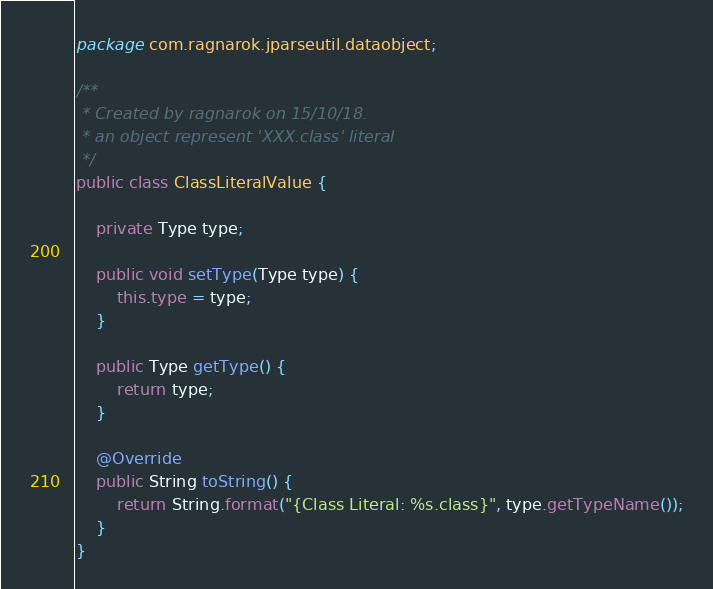<code> <loc_0><loc_0><loc_500><loc_500><_Java_>package com.ragnarok.jparseutil.dataobject;

/**
 * Created by ragnarok on 15/10/18.
 * an object represent 'XXX.class' literal
 */
public class ClassLiteralValue {
    
    private Type type;
    
    public void setType(Type type) {
        this.type = type;
    }
    
    public Type getType() {
        return type;
    }

    @Override
    public String toString() {
        return String.format("{Class Literal: %s.class}", type.getTypeName());
    }
}
</code> 